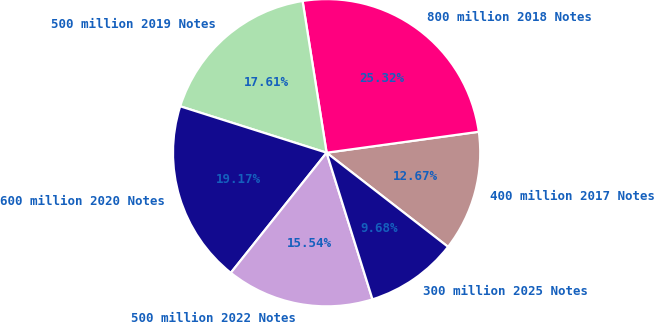Convert chart. <chart><loc_0><loc_0><loc_500><loc_500><pie_chart><fcel>400 million 2017 Notes<fcel>800 million 2018 Notes<fcel>500 million 2019 Notes<fcel>600 million 2020 Notes<fcel>500 million 2022 Notes<fcel>300 million 2025 Notes<nl><fcel>12.67%<fcel>25.32%<fcel>17.61%<fcel>19.17%<fcel>15.54%<fcel>9.68%<nl></chart> 